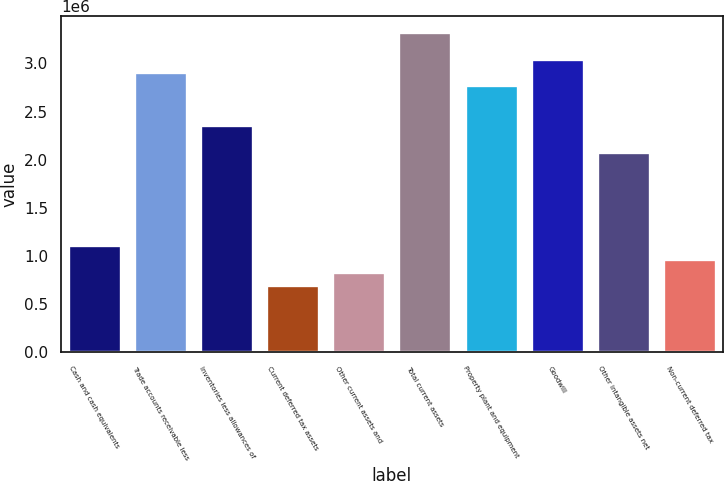Convert chart. <chart><loc_0><loc_0><loc_500><loc_500><bar_chart><fcel>Cash and cash equivalents<fcel>Trade accounts receivable less<fcel>Inventories less allowances of<fcel>Current deferred tax assets<fcel>Other current assets and<fcel>Total current assets<fcel>Property plant and equipment<fcel>Goodwill<fcel>Other intangible assets net<fcel>Non-current deferred tax<nl><fcel>1.10991e+06<fcel>2.91279e+06<fcel>2.35806e+06<fcel>693861<fcel>832544<fcel>3.32884e+06<fcel>2.77411e+06<fcel>3.05147e+06<fcel>2.08069e+06<fcel>971227<nl></chart> 